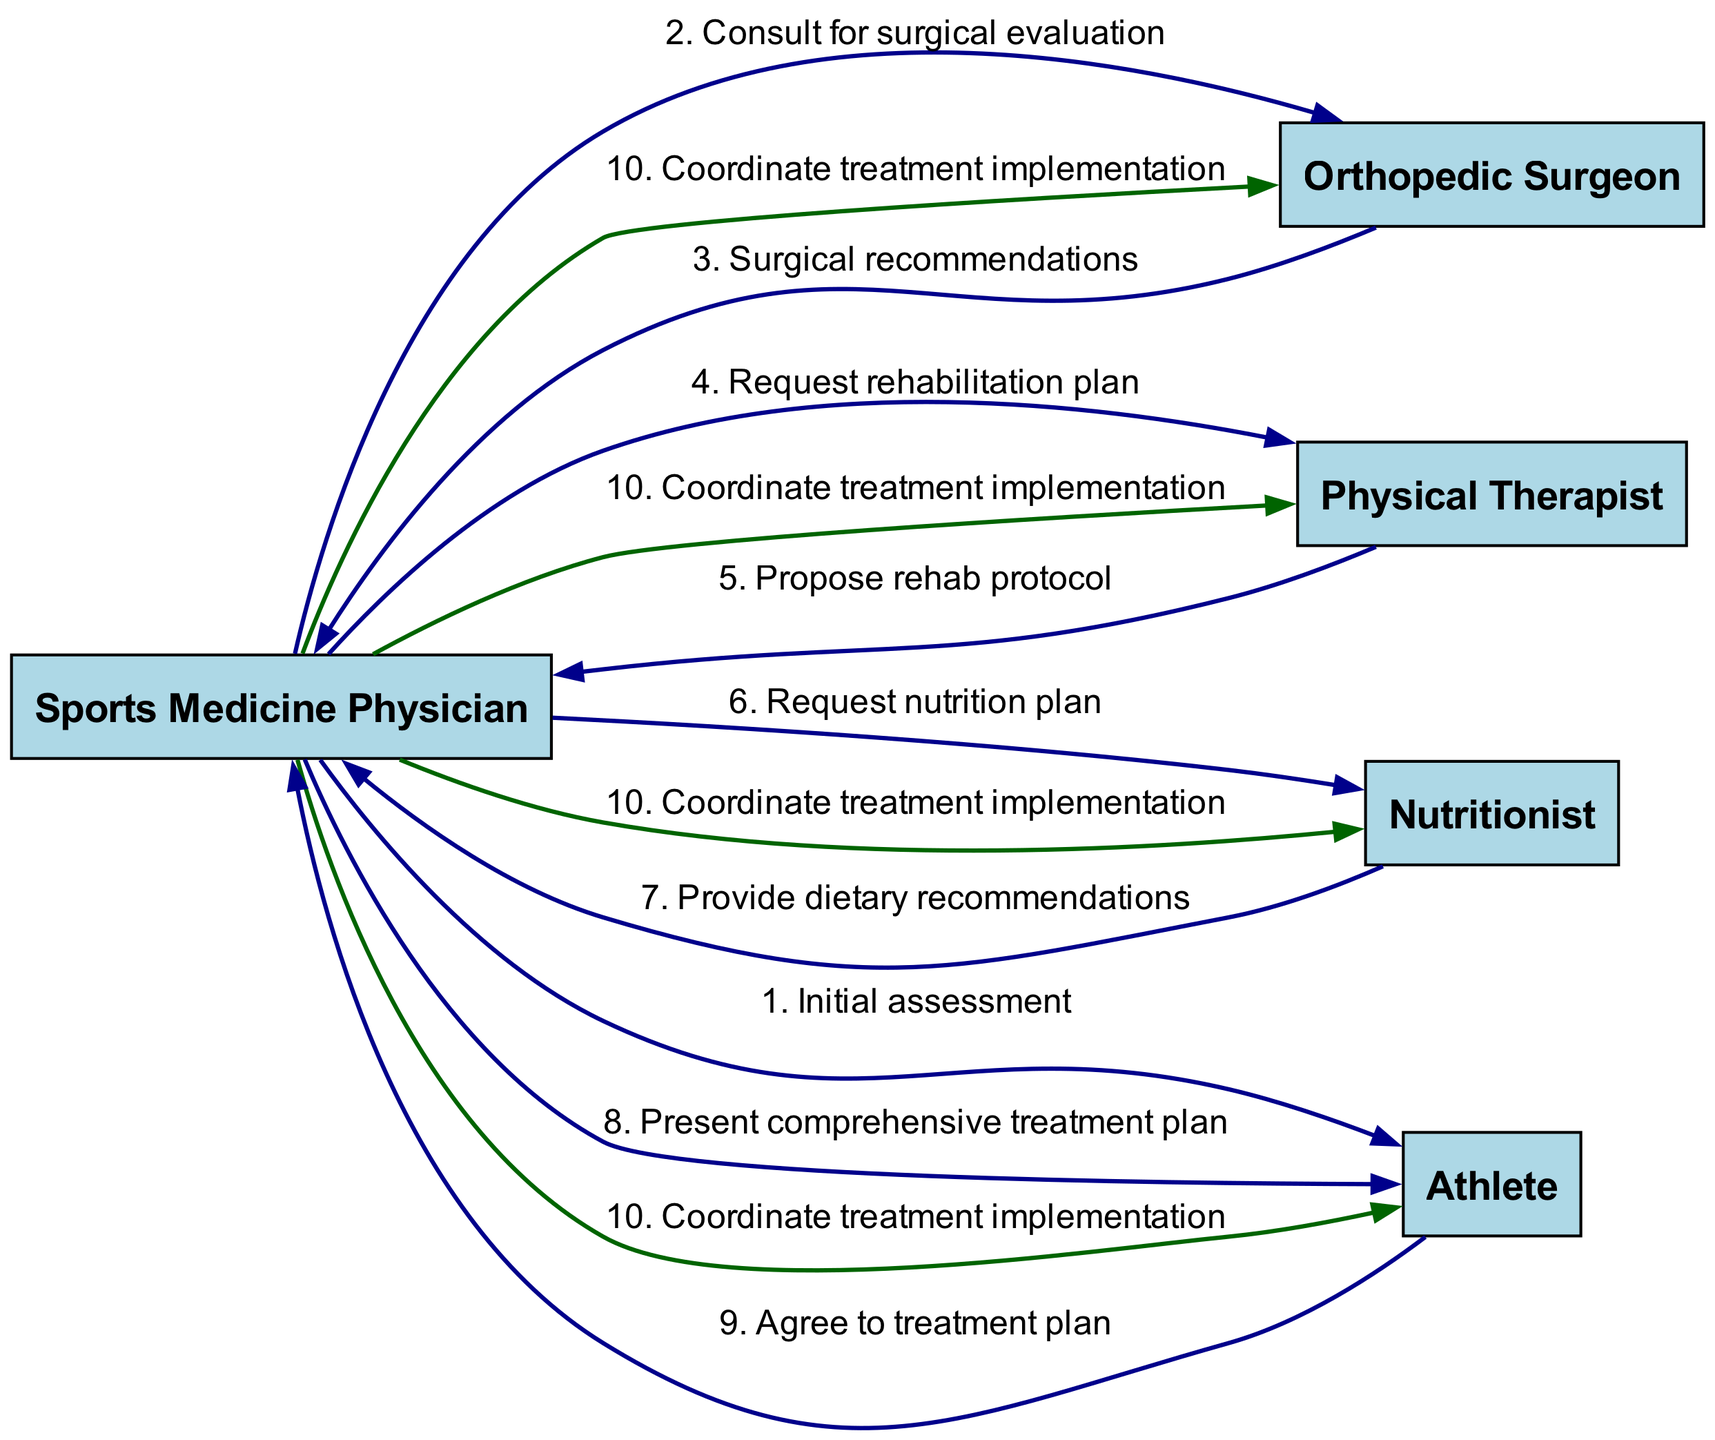What is the first action taken in the sequence? The first action involves the Sports Medicine Physician performing an initial assessment with the Athlete. This establishes the starting point of the treatment plan.
Answer: Initial assessment Who provides the surgical recommendations? The Orthopedic Surgeon is the one who provides the surgical recommendations to the Sports Medicine Physician after they consult for surgical evaluation.
Answer: Orthopedic Surgeon How many distinct specialists are involved in the treatment plan? There are four distinct specialists in the sequence: the Sports Medicine Physician, Orthopedic Surgeon, Physical Therapist, and Nutritionist, excluding the Athlete.
Answer: Four What is the last action before the treatment implementation? The last action before coordinating treatment implementation is the Athlete agreeing to the treatment plan presented by the Sports Medicine Physician.
Answer: Agree to treatment plan Which actors are directly involved in the request for a nutrition plan? The Sports Medicine Physician requests a nutrition plan from the Nutritionist, making these two the actors involved in this specific action.
Answer: Sports Medicine Physician and Nutritionist What type of action is taken after the Physical Therapist proposes a rehab protocol? After the Physical Therapist proposes a rehab protocol, the Sports Medicine Physician presents a comprehensive treatment plan to the Athlete, emphasizing the synthesis of the specialists' contributions.
Answer: Present comprehensive treatment plan How many edges originate from the Sports Medicine Physician? The Sports Medicine Physician has five outgoing edges: one to the Athlete (initial assessment), one to the Orthopedic Surgeon (consult), one to the Physical Therapist (rehabilitation plan), one to the Nutritionist (nutrition plan), and one to all (coordinate treatment implementation).
Answer: Five Which actor has the final say in agreeing to the treatment plan? The final decision-making on the agreement of the treatment plan lies with the Athlete, who communicates their consent to the Sports Medicine Physician.
Answer: Athlete In what sequence does the Nutritionist provide dietary recommendations? The Nutritionist provides dietary recommendations after the Sports Medicine Physician requests a nutrition plan, indicating a direct flow from the request to the provision of recommendations.
Answer: After the request for nutrition plan 